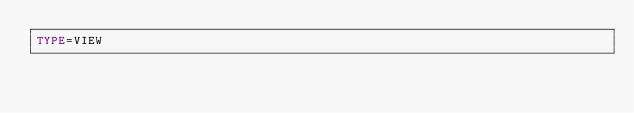<code> <loc_0><loc_0><loc_500><loc_500><_VisualBasic_>TYPE=VIEW</code> 